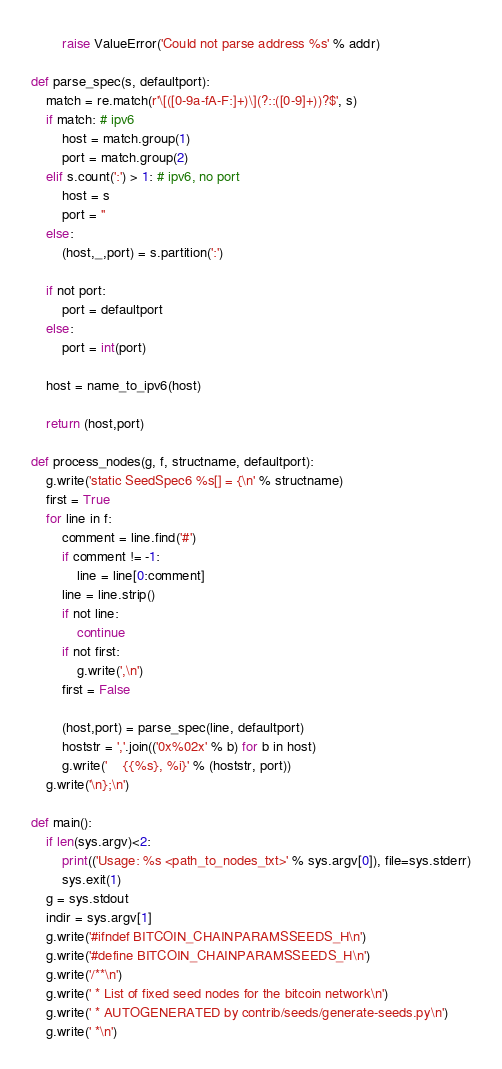<code> <loc_0><loc_0><loc_500><loc_500><_Python_>        raise ValueError('Could not parse address %s' % addr)

def parse_spec(s, defaultport):
    match = re.match(r'\[([0-9a-fA-F:]+)\](?::([0-9]+))?$', s)
    if match: # ipv6
        host = match.group(1)
        port = match.group(2)
    elif s.count(':') > 1: # ipv6, no port
        host = s
        port = ''
    else:
        (host,_,port) = s.partition(':')

    if not port:
        port = defaultport
    else:
        port = int(port)

    host = name_to_ipv6(host)

    return (host,port)

def process_nodes(g, f, structname, defaultport):
    g.write('static SeedSpec6 %s[] = {\n' % structname)
    first = True
    for line in f:
        comment = line.find('#')
        if comment != -1:
            line = line[0:comment]
        line = line.strip()
        if not line:
            continue
        if not first:
            g.write(',\n')
        first = False

        (host,port) = parse_spec(line, defaultport)
        hoststr = ','.join(('0x%02x' % b) for b in host)
        g.write('    {{%s}, %i}' % (hoststr, port))
    g.write('\n};\n')

def main():
    if len(sys.argv)<2:
        print(('Usage: %s <path_to_nodes_txt>' % sys.argv[0]), file=sys.stderr)
        sys.exit(1)
    g = sys.stdout
    indir = sys.argv[1]
    g.write('#ifndef BITCOIN_CHAINPARAMSSEEDS_H\n')
    g.write('#define BITCOIN_CHAINPARAMSSEEDS_H\n')
    g.write('/**\n')
    g.write(' * List of fixed seed nodes for the bitcoin network\n')
    g.write(' * AUTOGENERATED by contrib/seeds/generate-seeds.py\n')
    g.write(' *\n')</code> 